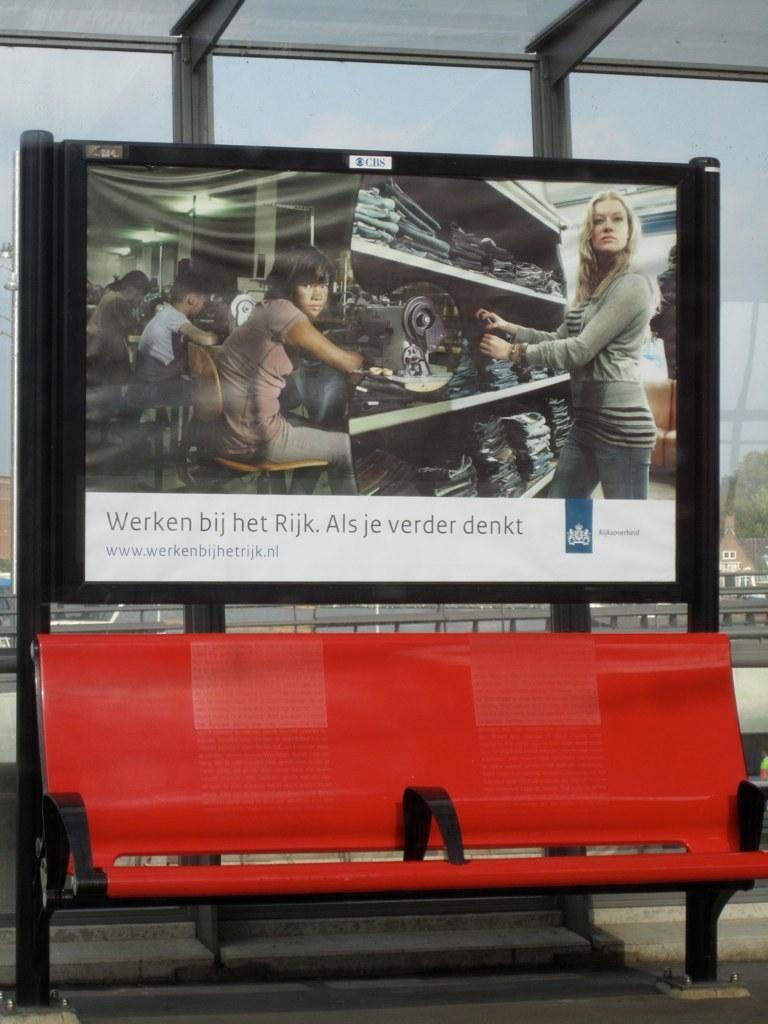How would you summarize this image in a sentence or two? In this image we can see a bench and we can also see a poster on the stand and behind that we can see the glass windows. 